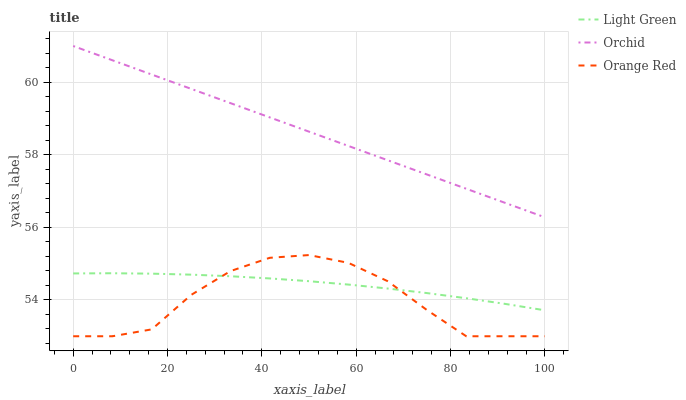Does Orange Red have the minimum area under the curve?
Answer yes or no. Yes. Does Orchid have the maximum area under the curve?
Answer yes or no. Yes. Does Light Green have the minimum area under the curve?
Answer yes or no. No. Does Light Green have the maximum area under the curve?
Answer yes or no. No. Is Orchid the smoothest?
Answer yes or no. Yes. Is Orange Red the roughest?
Answer yes or no. Yes. Is Light Green the smoothest?
Answer yes or no. No. Is Light Green the roughest?
Answer yes or no. No. Does Orange Red have the lowest value?
Answer yes or no. Yes. Does Light Green have the lowest value?
Answer yes or no. No. Does Orchid have the highest value?
Answer yes or no. Yes. Does Light Green have the highest value?
Answer yes or no. No. Is Orange Red less than Orchid?
Answer yes or no. Yes. Is Orchid greater than Orange Red?
Answer yes or no. Yes. Does Orange Red intersect Light Green?
Answer yes or no. Yes. Is Orange Red less than Light Green?
Answer yes or no. No. Is Orange Red greater than Light Green?
Answer yes or no. No. Does Orange Red intersect Orchid?
Answer yes or no. No. 